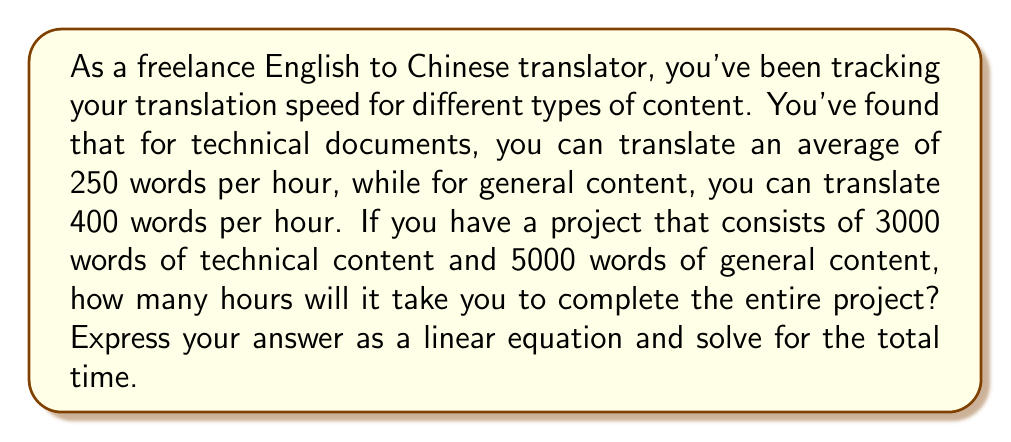Can you solve this math problem? Let's approach this step-by-step:

1) First, let's define our variables:
   $t_1$ = time for technical content (in hours)
   $t_2$ = time for general content (in hours)

2) Now, we can set up equations based on the given information:
   For technical content: $250t_1 = 3000$
   For general content: $400t_2 = 5000$

3) Solve each equation:
   $t_1 = 3000 / 250 = 12$ hours
   $t_2 = 5000 / 400 = 12.5$ hours

4) The total time $T$ is the sum of $t_1$ and $t_2$:
   $T = t_1 + t_2$

5) Substituting the values:
   $T = 12 + 12.5 = 24.5$ hours

6) To express this as a linear equation in terms of word count, let:
   $x$ = number of technical words
   $y$ = number of general words
   
   Then our equation becomes:
   $$T = \frac{x}{250} + \frac{y}{400}$$

7) For this specific project:
   $$T = \frac{3000}{250} + \frac{5000}{400} = 12 + 12.5 = 24.5$$

This linear equation allows you to calculate the total translation time for any combination of technical and general content word counts.
Answer: The linear equation for translation time is:
$$T = \frac{x}{250} + \frac{y}{400}$$
where $x$ is the number of technical words and $y$ is the number of general words.

For the given project, the total translation time is 24.5 hours. 